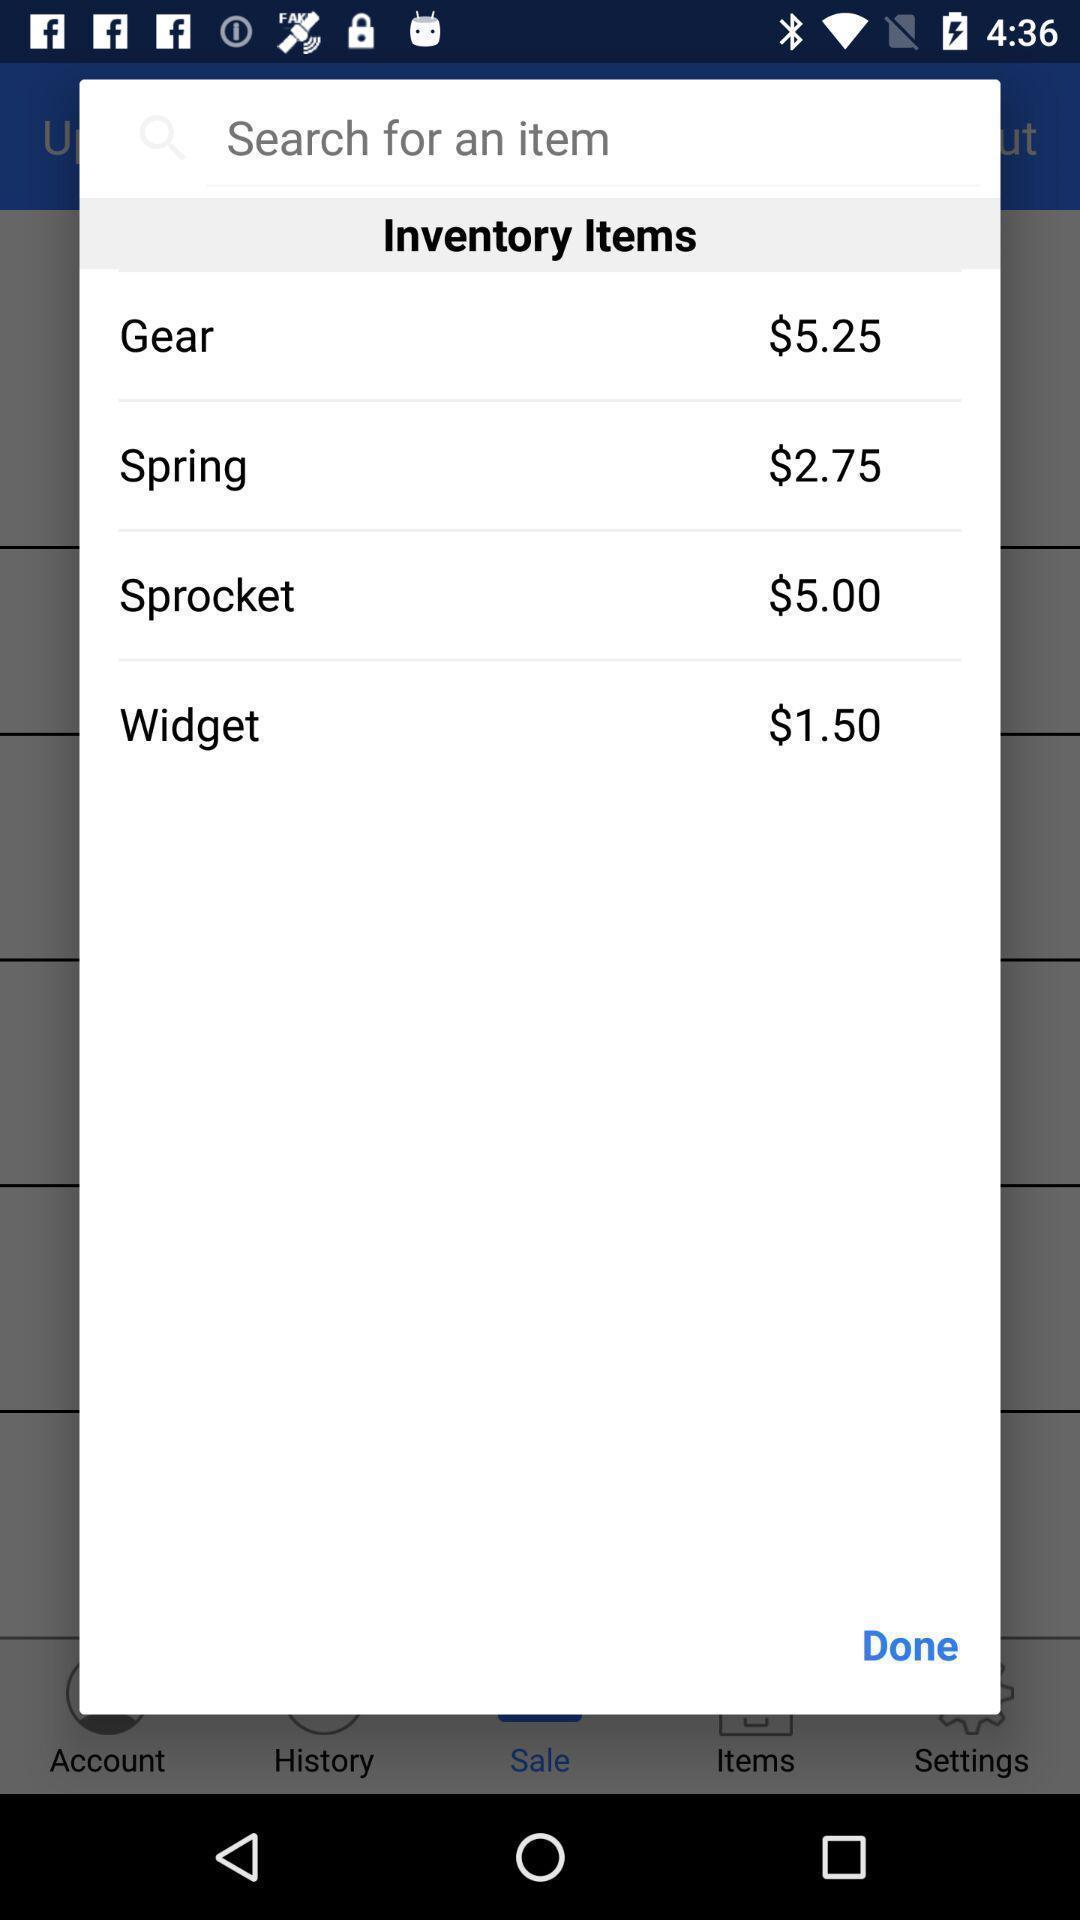Tell me about the visual elements in this screen capture. Pop-up shows to search for an item. 